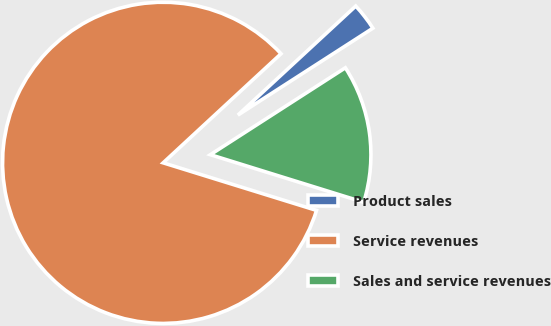<chart> <loc_0><loc_0><loc_500><loc_500><pie_chart><fcel>Product sales<fcel>Service revenues<fcel>Sales and service revenues<nl><fcel>2.78%<fcel>83.33%<fcel>13.89%<nl></chart> 